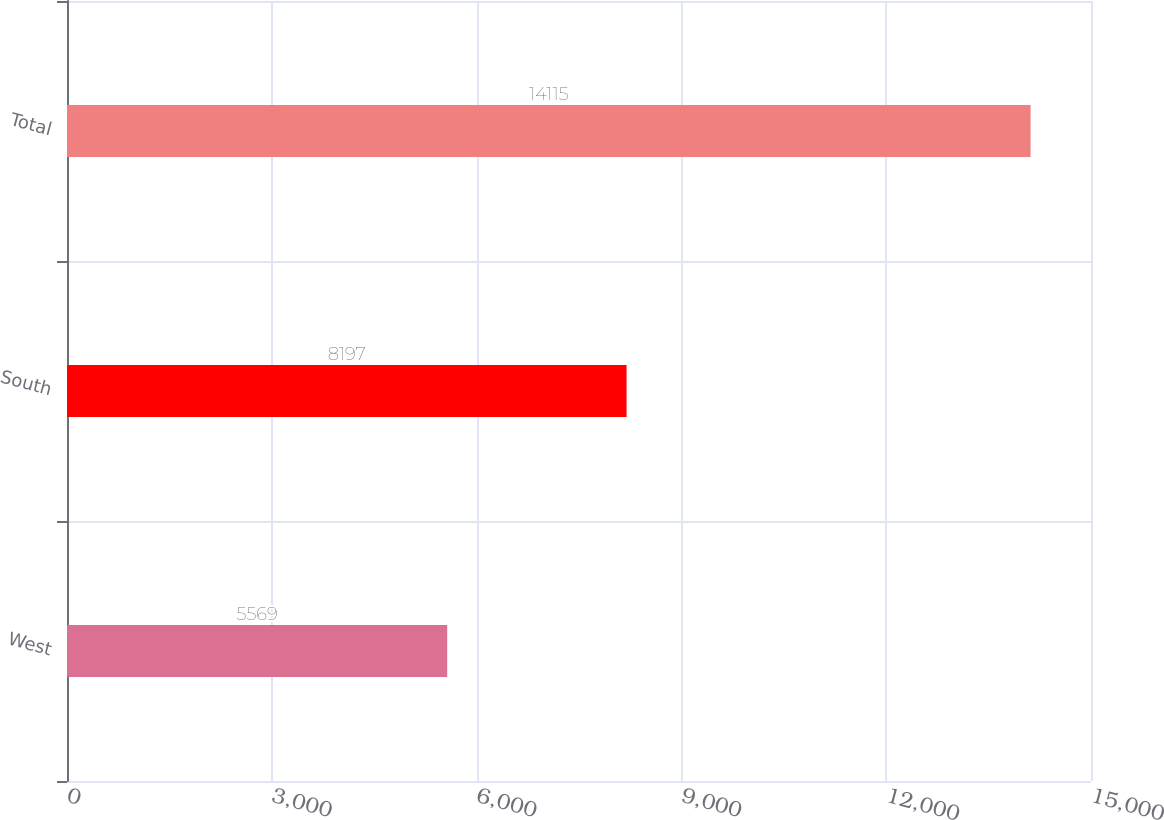Convert chart. <chart><loc_0><loc_0><loc_500><loc_500><bar_chart><fcel>West<fcel>South<fcel>Total<nl><fcel>5569<fcel>8197<fcel>14115<nl></chart> 